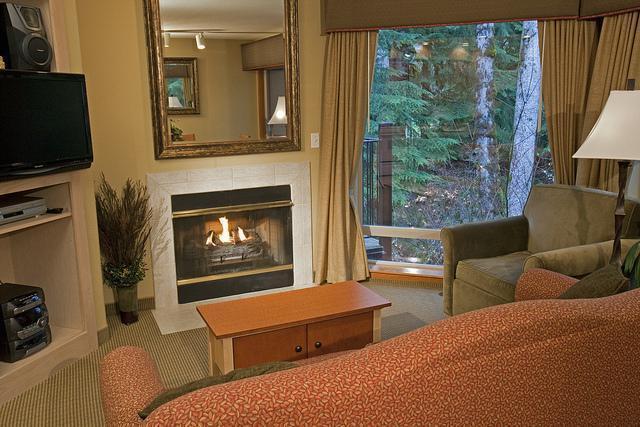What is the most likely floor level for this room?
Choose the correct response, then elucidate: 'Answer: answer
Rationale: rationale.'
Options: First/second, fifth/sixth, third/fourth, seventh/eighth. Answer: first/second.
Rationale: There is a deck just outside the window and they are only on these floors 